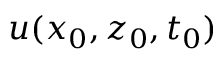Convert formula to latex. <formula><loc_0><loc_0><loc_500><loc_500>u ( x _ { 0 } , z _ { 0 } , t _ { 0 } )</formula> 